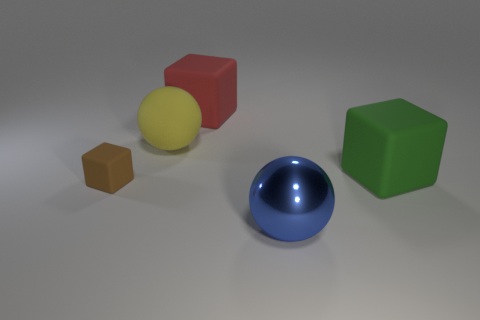Add 1 red rubber cubes. How many objects exist? 6 Subtract all balls. How many objects are left? 3 Add 3 brown rubber blocks. How many brown rubber blocks are left? 4 Add 2 rubber things. How many rubber things exist? 6 Subtract 0 blue cylinders. How many objects are left? 5 Subtract all big green things. Subtract all large spheres. How many objects are left? 2 